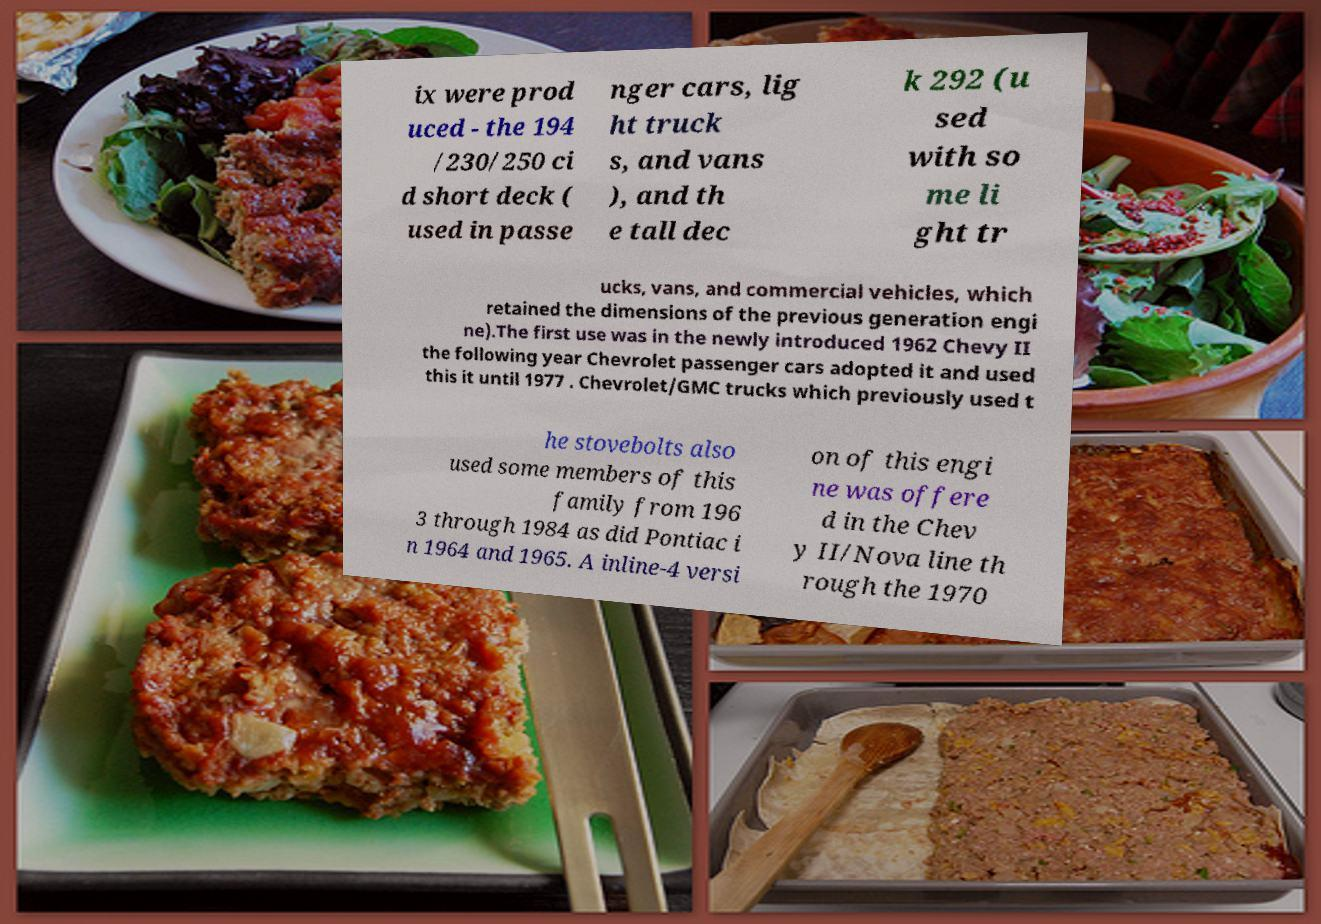There's text embedded in this image that I need extracted. Can you transcribe it verbatim? ix were prod uced - the 194 /230/250 ci d short deck ( used in passe nger cars, lig ht truck s, and vans ), and th e tall dec k 292 (u sed with so me li ght tr ucks, vans, and commercial vehicles, which retained the dimensions of the previous generation engi ne).The first use was in the newly introduced 1962 Chevy II the following year Chevrolet passenger cars adopted it and used this it until 1977 . Chevrolet/GMC trucks which previously used t he stovebolts also used some members of this family from 196 3 through 1984 as did Pontiac i n 1964 and 1965. A inline-4 versi on of this engi ne was offere d in the Chev y II/Nova line th rough the 1970 